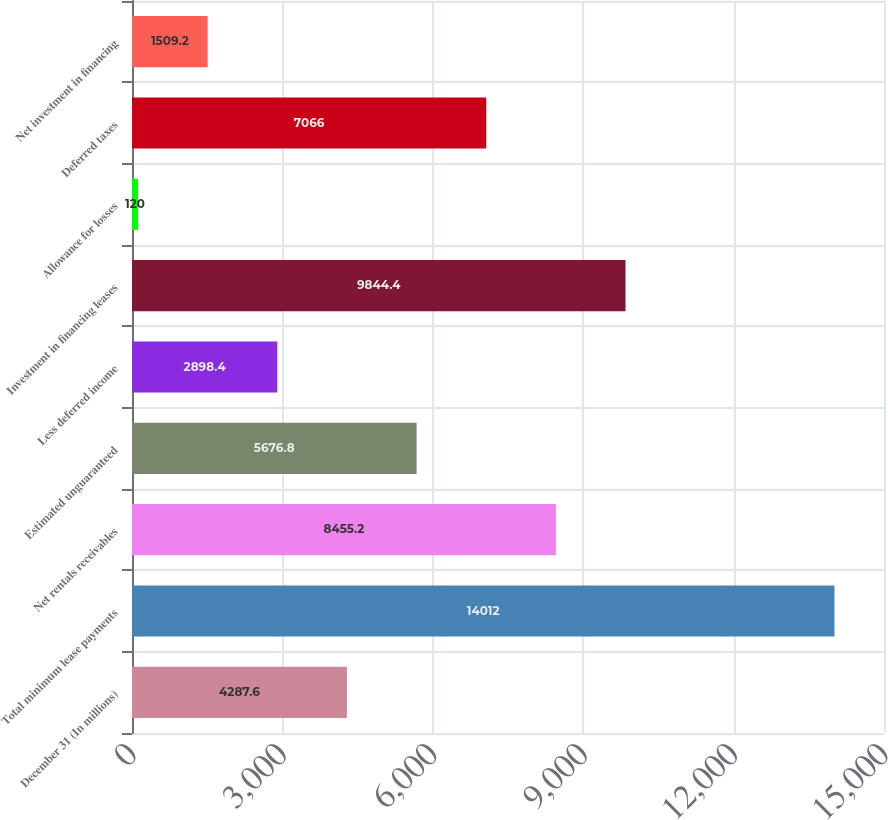Convert chart to OTSL. <chart><loc_0><loc_0><loc_500><loc_500><bar_chart><fcel>December 31 (In millions)<fcel>Total minimum lease payments<fcel>Net rentals receivables<fcel>Estimated unguaranteed<fcel>Less deferred income<fcel>Investment in financing leases<fcel>Allowance for losses<fcel>Deferred taxes<fcel>Net investment in financing<nl><fcel>4287.6<fcel>14012<fcel>8455.2<fcel>5676.8<fcel>2898.4<fcel>9844.4<fcel>120<fcel>7066<fcel>1509.2<nl></chart> 